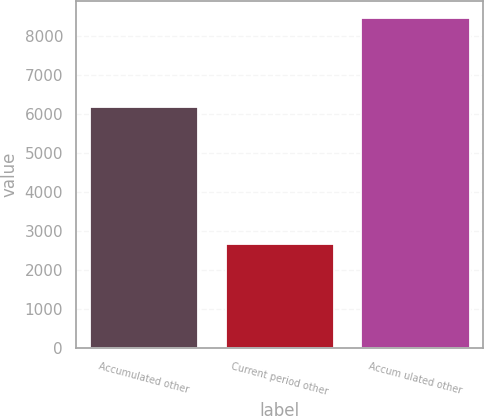<chart> <loc_0><loc_0><loc_500><loc_500><bar_chart><fcel>Accumulated other<fcel>Current period other<fcel>Accum ulated other<nl><fcel>6158<fcel>2672<fcel>8454<nl></chart> 